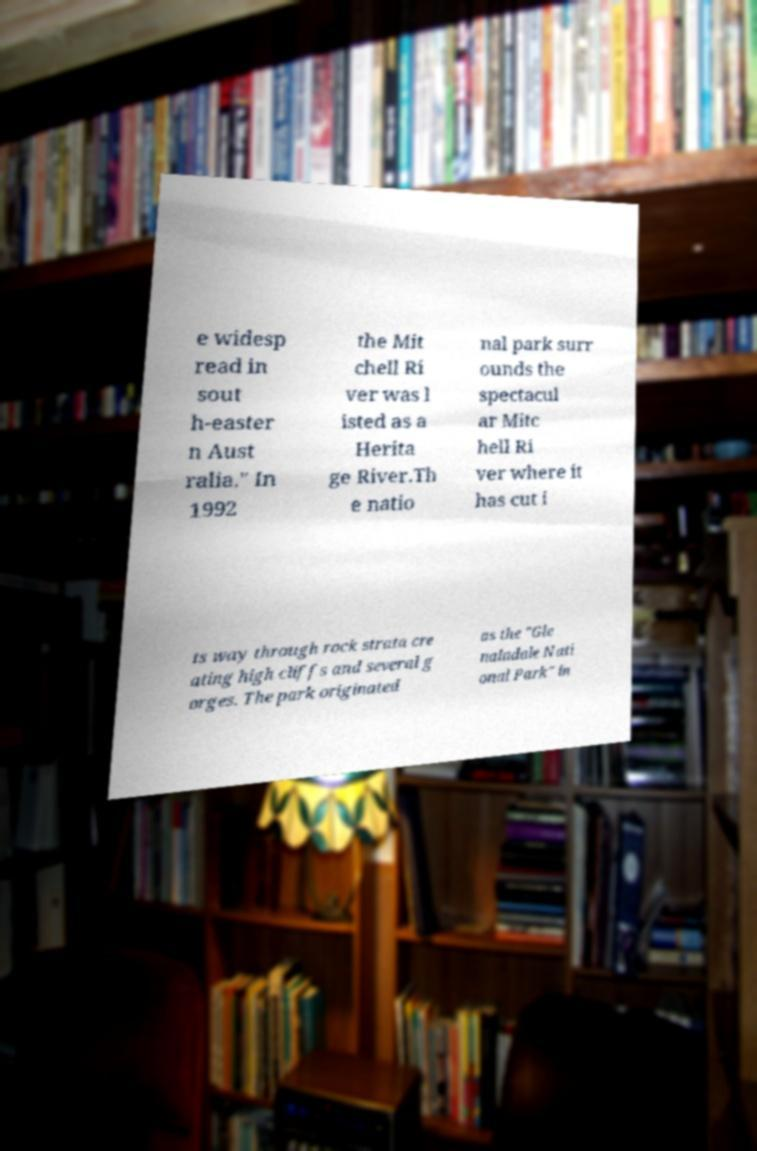Can you read and provide the text displayed in the image?This photo seems to have some interesting text. Can you extract and type it out for me? e widesp read in sout h-easter n Aust ralia." In 1992 the Mit chell Ri ver was l isted as a Herita ge River.Th e natio nal park surr ounds the spectacul ar Mitc hell Ri ver where it has cut i ts way through rock strata cre ating high cliffs and several g orges. The park originated as the "Gle naladale Nati onal Park" in 